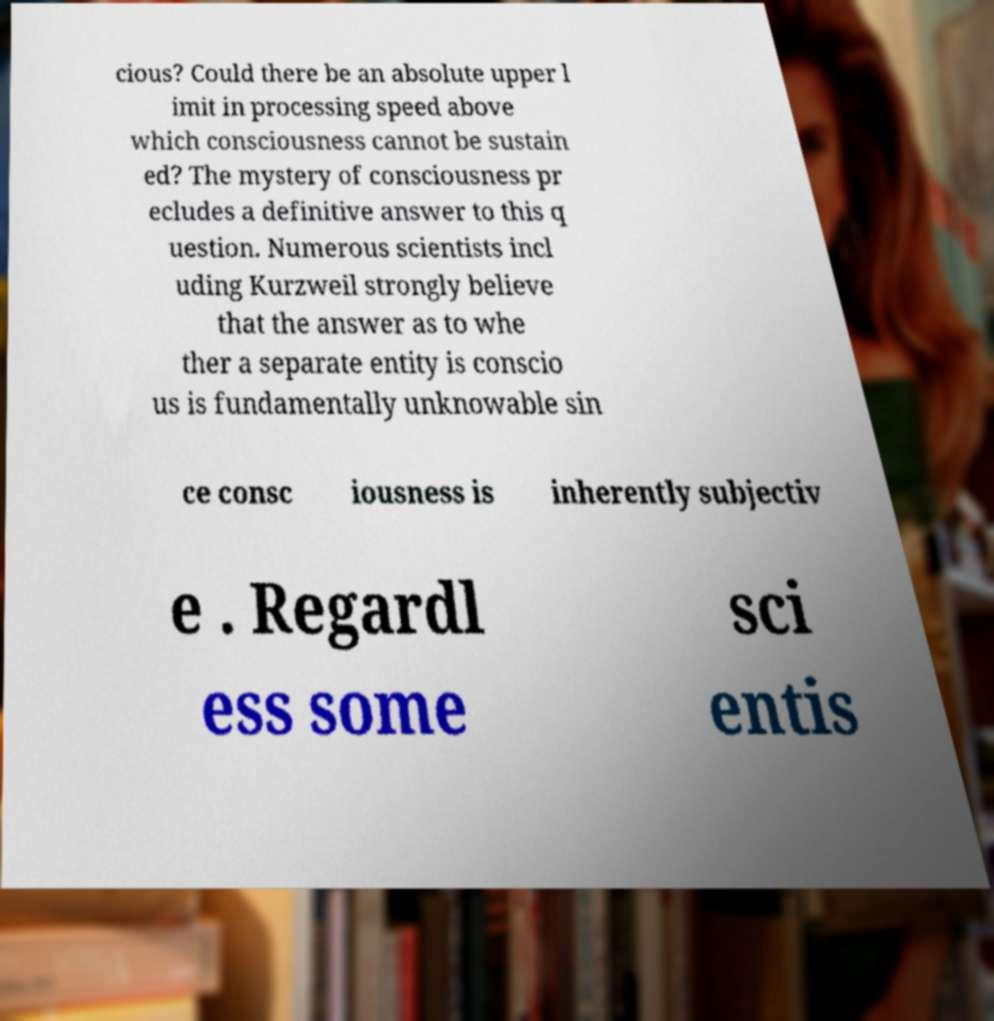Can you read and provide the text displayed in the image?This photo seems to have some interesting text. Can you extract and type it out for me? cious? Could there be an absolute upper l imit in processing speed above which consciousness cannot be sustain ed? The mystery of consciousness pr ecludes a definitive answer to this q uestion. Numerous scientists incl uding Kurzweil strongly believe that the answer as to whe ther a separate entity is conscio us is fundamentally unknowable sin ce consc iousness is inherently subjectiv e . Regardl ess some sci entis 